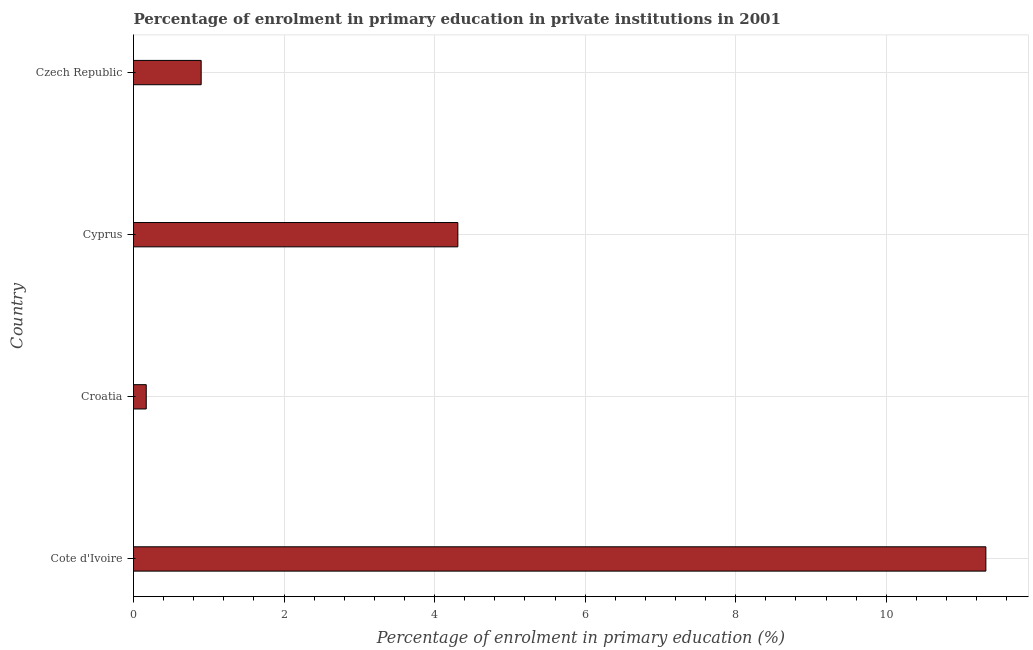Does the graph contain grids?
Make the answer very short. Yes. What is the title of the graph?
Provide a short and direct response. Percentage of enrolment in primary education in private institutions in 2001. What is the label or title of the X-axis?
Ensure brevity in your answer.  Percentage of enrolment in primary education (%). What is the enrolment percentage in primary education in Croatia?
Provide a succinct answer. 0.17. Across all countries, what is the maximum enrolment percentage in primary education?
Offer a very short reply. 11.32. Across all countries, what is the minimum enrolment percentage in primary education?
Keep it short and to the point. 0.17. In which country was the enrolment percentage in primary education maximum?
Your answer should be very brief. Cote d'Ivoire. In which country was the enrolment percentage in primary education minimum?
Offer a very short reply. Croatia. What is the sum of the enrolment percentage in primary education?
Your answer should be compact. 16.7. What is the difference between the enrolment percentage in primary education in Croatia and Cyprus?
Make the answer very short. -4.14. What is the average enrolment percentage in primary education per country?
Give a very brief answer. 4.17. What is the median enrolment percentage in primary education?
Ensure brevity in your answer.  2.6. In how many countries, is the enrolment percentage in primary education greater than 6.4 %?
Ensure brevity in your answer.  1. What is the ratio of the enrolment percentage in primary education in Croatia to that in Cyprus?
Offer a terse response. 0.04. Is the enrolment percentage in primary education in Cote d'Ivoire less than that in Cyprus?
Provide a succinct answer. No. What is the difference between the highest and the second highest enrolment percentage in primary education?
Your response must be concise. 7.01. Is the sum of the enrolment percentage in primary education in Croatia and Czech Republic greater than the maximum enrolment percentage in primary education across all countries?
Offer a very short reply. No. What is the difference between the highest and the lowest enrolment percentage in primary education?
Your answer should be very brief. 11.15. In how many countries, is the enrolment percentage in primary education greater than the average enrolment percentage in primary education taken over all countries?
Keep it short and to the point. 2. How many bars are there?
Your answer should be very brief. 4. Are all the bars in the graph horizontal?
Provide a succinct answer. Yes. How many countries are there in the graph?
Ensure brevity in your answer.  4. What is the difference between two consecutive major ticks on the X-axis?
Your response must be concise. 2. What is the Percentage of enrolment in primary education (%) of Cote d'Ivoire?
Offer a terse response. 11.32. What is the Percentage of enrolment in primary education (%) in Croatia?
Your answer should be compact. 0.17. What is the Percentage of enrolment in primary education (%) of Cyprus?
Make the answer very short. 4.31. What is the Percentage of enrolment in primary education (%) of Czech Republic?
Make the answer very short. 0.9. What is the difference between the Percentage of enrolment in primary education (%) in Cote d'Ivoire and Croatia?
Provide a short and direct response. 11.15. What is the difference between the Percentage of enrolment in primary education (%) in Cote d'Ivoire and Cyprus?
Keep it short and to the point. 7.01. What is the difference between the Percentage of enrolment in primary education (%) in Cote d'Ivoire and Czech Republic?
Offer a terse response. 10.42. What is the difference between the Percentage of enrolment in primary education (%) in Croatia and Cyprus?
Your response must be concise. -4.14. What is the difference between the Percentage of enrolment in primary education (%) in Croatia and Czech Republic?
Your answer should be compact. -0.73. What is the difference between the Percentage of enrolment in primary education (%) in Cyprus and Czech Republic?
Offer a very short reply. 3.41. What is the ratio of the Percentage of enrolment in primary education (%) in Cote d'Ivoire to that in Croatia?
Provide a succinct answer. 66.93. What is the ratio of the Percentage of enrolment in primary education (%) in Cote d'Ivoire to that in Cyprus?
Your response must be concise. 2.63. What is the ratio of the Percentage of enrolment in primary education (%) in Cote d'Ivoire to that in Czech Republic?
Give a very brief answer. 12.6. What is the ratio of the Percentage of enrolment in primary education (%) in Croatia to that in Cyprus?
Ensure brevity in your answer.  0.04. What is the ratio of the Percentage of enrolment in primary education (%) in Croatia to that in Czech Republic?
Give a very brief answer. 0.19. What is the ratio of the Percentage of enrolment in primary education (%) in Cyprus to that in Czech Republic?
Make the answer very short. 4.79. 